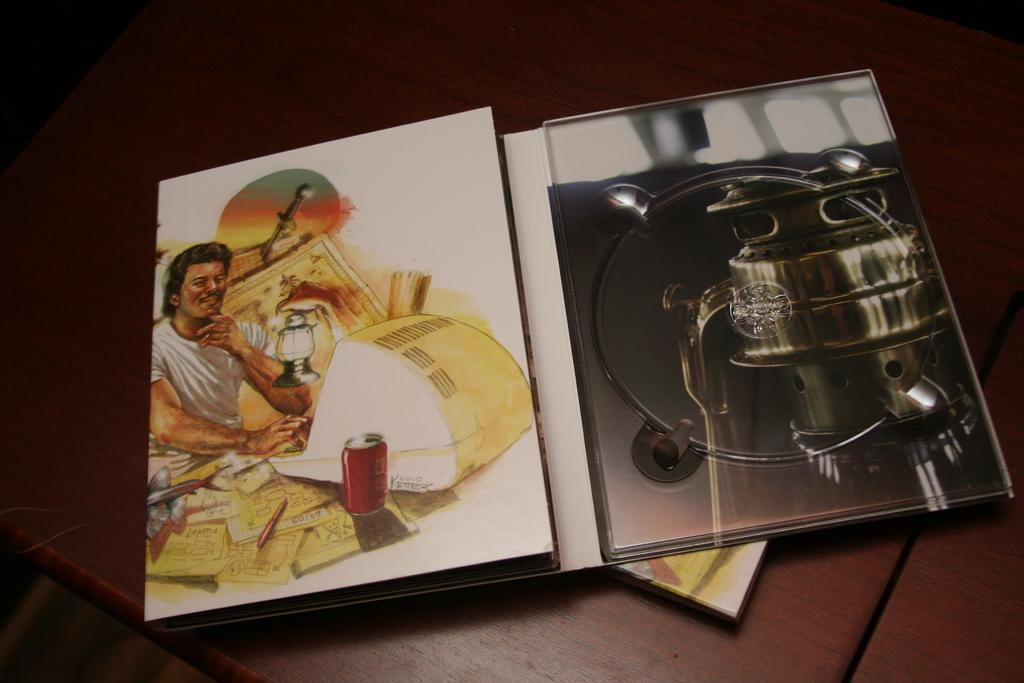What piece of furniture is present in the image? There is a table in the image. What object related to drawing or sketching can be seen on the table? There is a drawing book on the table. What type of meat is being served at the airport in the image? There is no meat or airport present in the image; it only features a table with a drawing book on it. 